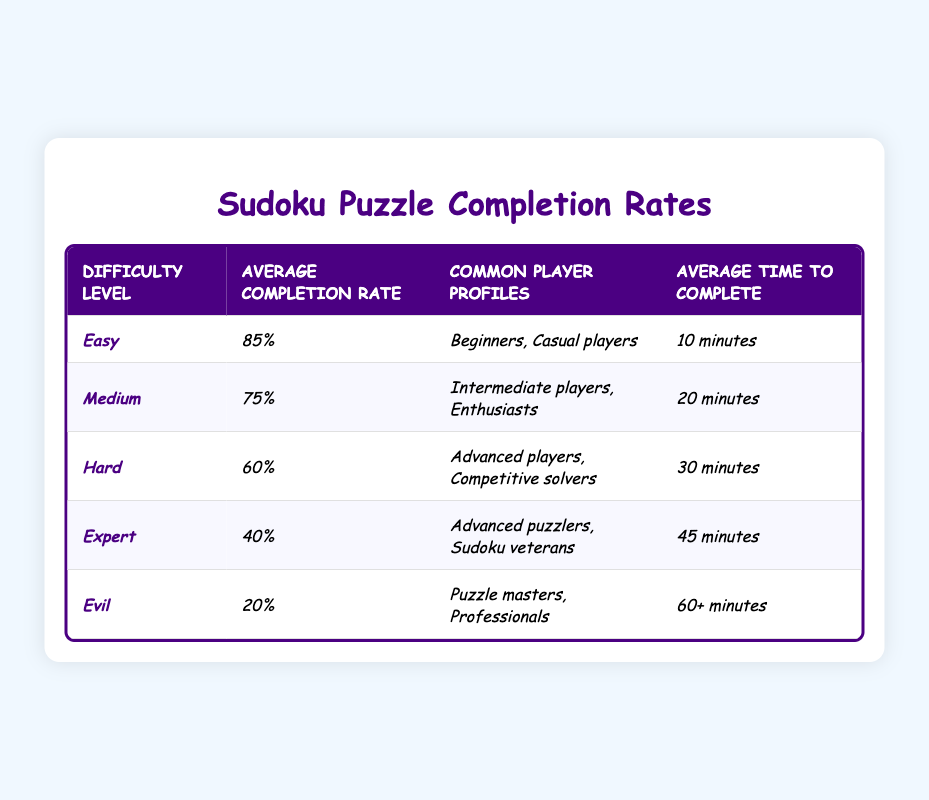What is the average completion rate for Easy Sudoku puzzles? The table shows that the average completion rate for the Easy difficulty level is listed as 85%.
Answer: 85% Which difficulty level has the highest average completion rate? Looking at the table, the Easy level has the highest average completion rate of 85%.
Answer: Easy How much longer does it take on average to complete an Expert puzzle compared to a Medium puzzle? The average time to complete an Expert puzzle is 45 minutes and for Medium, it is 20 minutes. The difference is 45 - 20 = 25 minutes.
Answer: 25 minutes What player profiles are common for Hard Sudoku puzzles? The table states that the common player profiles for Hard puzzles are Advanced players and Competitive solvers.
Answer: Advanced players, Competitive solvers Is the average completion rate for Evil puzzles greater than 30%? The completion rate for Evil puzzles is 20%, which is less than 30%. Therefore, the answer is no.
Answer: No If you combine the average completion rates for Easy and Medium puzzles, what would that total be? The average completion rate for Easy is 85% and for Medium is 75%. Adding these gives 85 + 75 = 160%.
Answer: 160% What percentage of players are expected to complete an Evil Sudoku puzzle? The table states that the average completion rate for Evil puzzles is 20%.
Answer: 20% Which puzzle difficulty level takes the most time to complete? The table indicates that Evil puzzles take the longest time to complete, at 60+ minutes.
Answer: Evil How does the average completion rate for Expert puzzles compare to that for Hard puzzles? The average completion rate for Expert puzzles is 40%, while for Hard puzzles, it is 60%. Thus, Expert is 20% lower than Hard.
Answer: Expert puzzles are 20% lower Which difficulty level has the lowest average time to complete? Reviewing the table, Easy puzzles have the lowest average time to complete, at 10 minutes.
Answer: Easy Do more casual players prefer Easy or Hard Sudoku puzzles based on the common player profiles provided? The table shows that Beginners and Casual players are common for Easy puzzles, whereas Hard is for Advanced players. Therefore, casual players prefer Easy.
Answer: Easy 